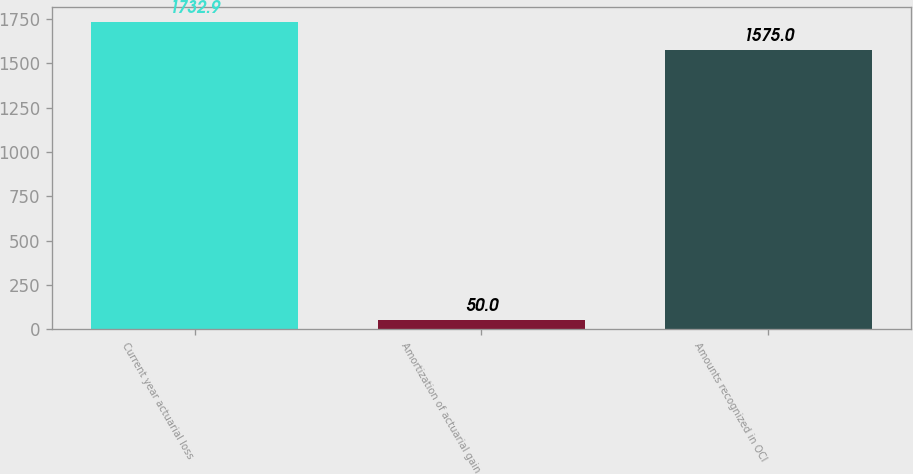<chart> <loc_0><loc_0><loc_500><loc_500><bar_chart><fcel>Current year actuarial loss<fcel>Amortization of actuarial gain<fcel>Amounts recognized in OCI<nl><fcel>1732.9<fcel>50<fcel>1575<nl></chart> 